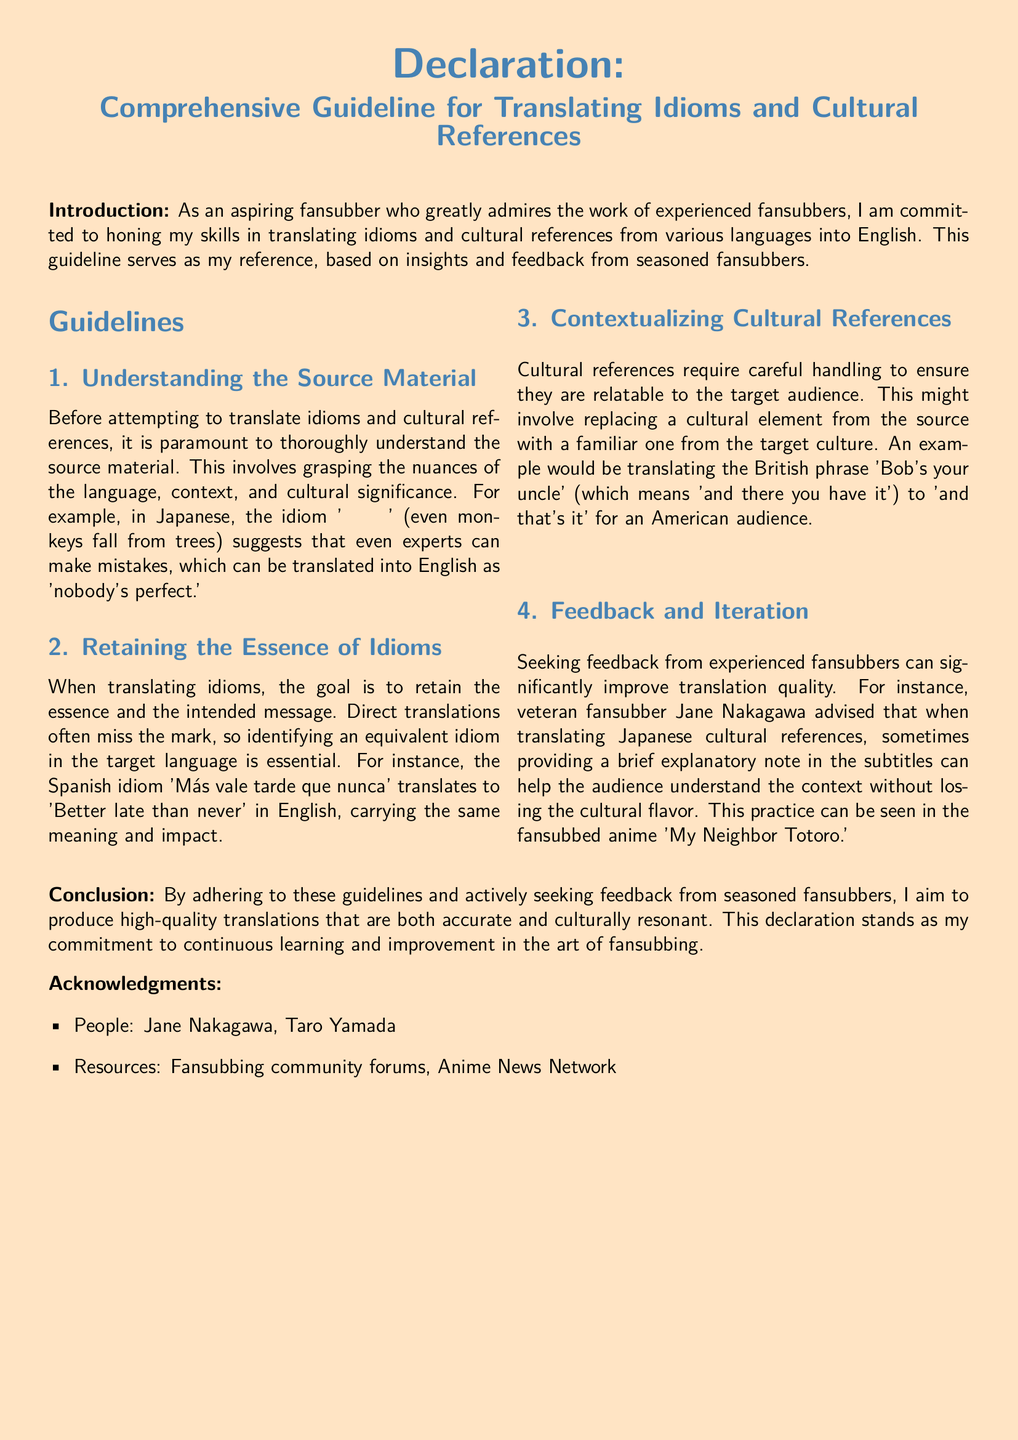What is the title of the guideline? The title is explicitly stated in the declaration section of the document.
Answer: Comprehensive Guideline for Translating Idioms and Cultural References Who provided feedback on translating Japanese cultural references? The document mentions a specific individual who gave advice regarding this topic.
Answer: Jane Nakagawa What idiom is used to imply that even experts can make mistakes? The document provides an example of a Japanese idiom with this meaning.
Answer: 猿も木から落ちる What is one example of a cultural reference translation mentioned? The document provides a specific example of translating a British phrase for an American audience.
Answer: Bob's your uncle How many sections are there under the guidelines? The guidelines section includes multiple subsections, and counting them will provide the required number.
Answer: 4 What resources are acknowledged in the document? The document lists resources at the end, which includes specific types.
Answer: Fansubbing community forums, Anime News Network What is the goal when translating idioms according to the document? The document outlines a primary objective that every translator should strive for when dealing with idioms.
Answer: Retaining the essence of idioms What cultural significance does the idiom 'Más vale tarde que nunca' carry? The document provides a translation of this idiom that conveys its meaning.
Answer: Better late than never 